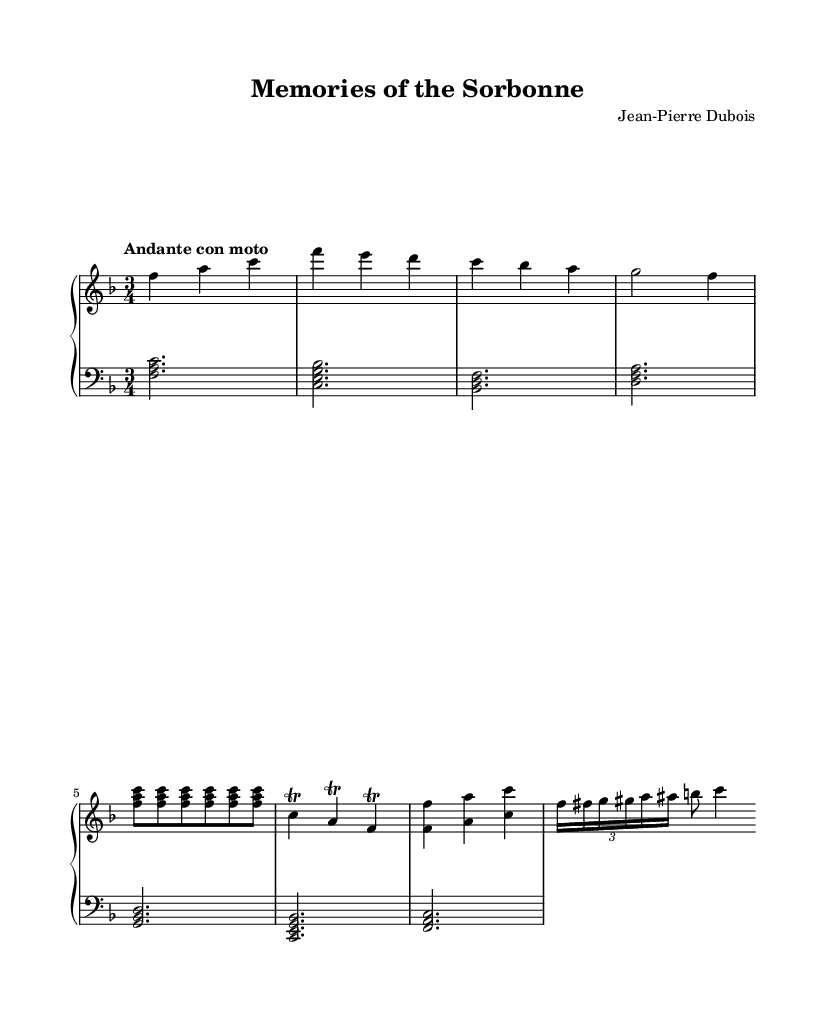What is the key signature of this music? The key signature is based on the indicated key, F major, which has one flat (B flat).
Answer: F major What is the time signature of this music? The time signature can be found at the beginning of the score; it is written as a fraction, showing there are three beats in a measure.
Answer: 3/4 What is the tempo marking for this piece? The tempo marking is provided above the staff and expresses the character of the music. It is stated as "Andante con moto."
Answer: Andante con moto How many measures are in the right hand part? By counting the individual groups of notes separated by vertical lines within the right hand section, we find that there are a total of 8 measures.
Answer: 8 Which instrument is this piece written for? The score features a 'PianoStaff', which indicates that this music is intended for the piano instrument.
Answer: Piano What is the primary musical theme used in the right hand? The right hand begins with a defined melody, which consists mainly of a repeating motif that can be observed in the main melodic line.
Answer: Main melody Do any sections of the music feature trills? The right hand indicates specific ornamentations known as trills appearing in the written notes, which are marked by the word "trill" after certain notes.
Answer: Yes 